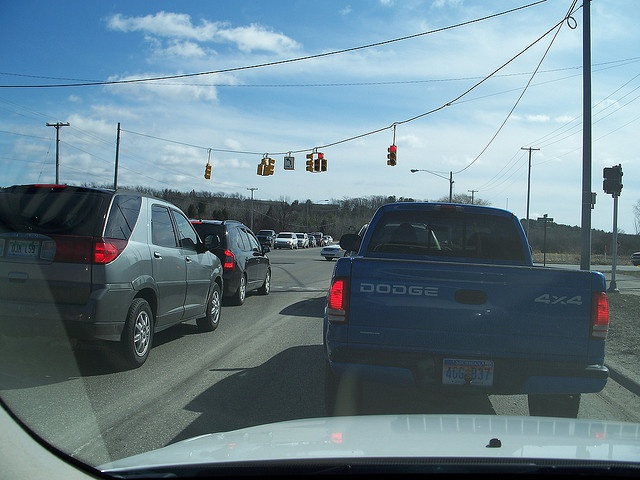Describe the objects in this image and their specific colors. I can see truck in blue, black, darkblue, and purple tones, car in blue, black, gray, and purple tones, car in blue, black, purple, gray, and darkgray tones, traffic light in blue, black, and purple tones, and car in blue, black, gray, and darkgray tones in this image. 